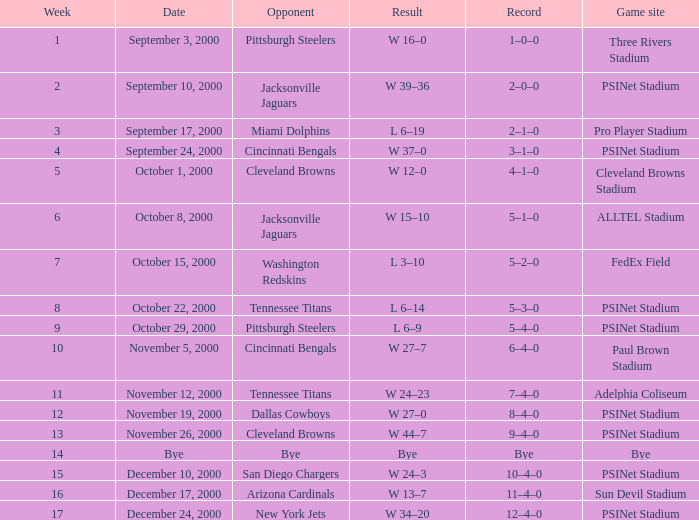What's the standing after week 12 with a match location of bye? Bye. 